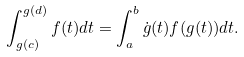Convert formula to latex. <formula><loc_0><loc_0><loc_500><loc_500>\int _ { g ( c ) } ^ { g ( d ) } f ( t ) d t = \int _ { a } ^ { b } \dot { g } ( t ) f ( g ( t ) ) d t .</formula> 